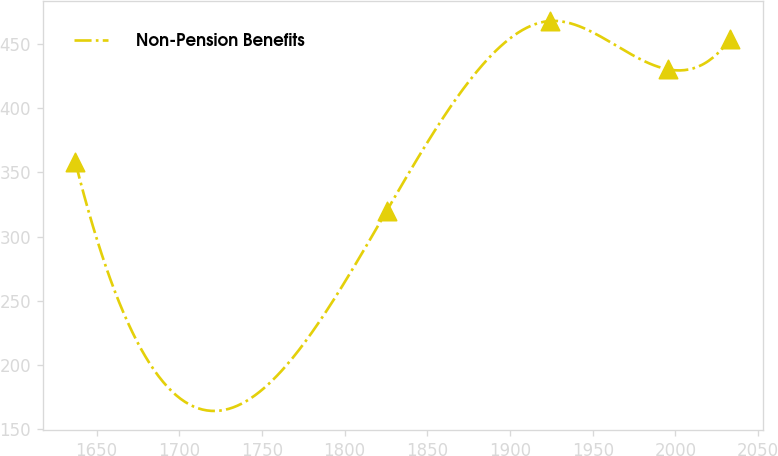<chart> <loc_0><loc_0><loc_500><loc_500><line_chart><ecel><fcel>Non-Pension Benefits<nl><fcel>1637.18<fcel>358.04<nl><fcel>1825.39<fcel>319.96<nl><fcel>1924.26<fcel>467.9<nl><fcel>1995.6<fcel>430.23<nl><fcel>2033.27<fcel>454.17<nl></chart> 